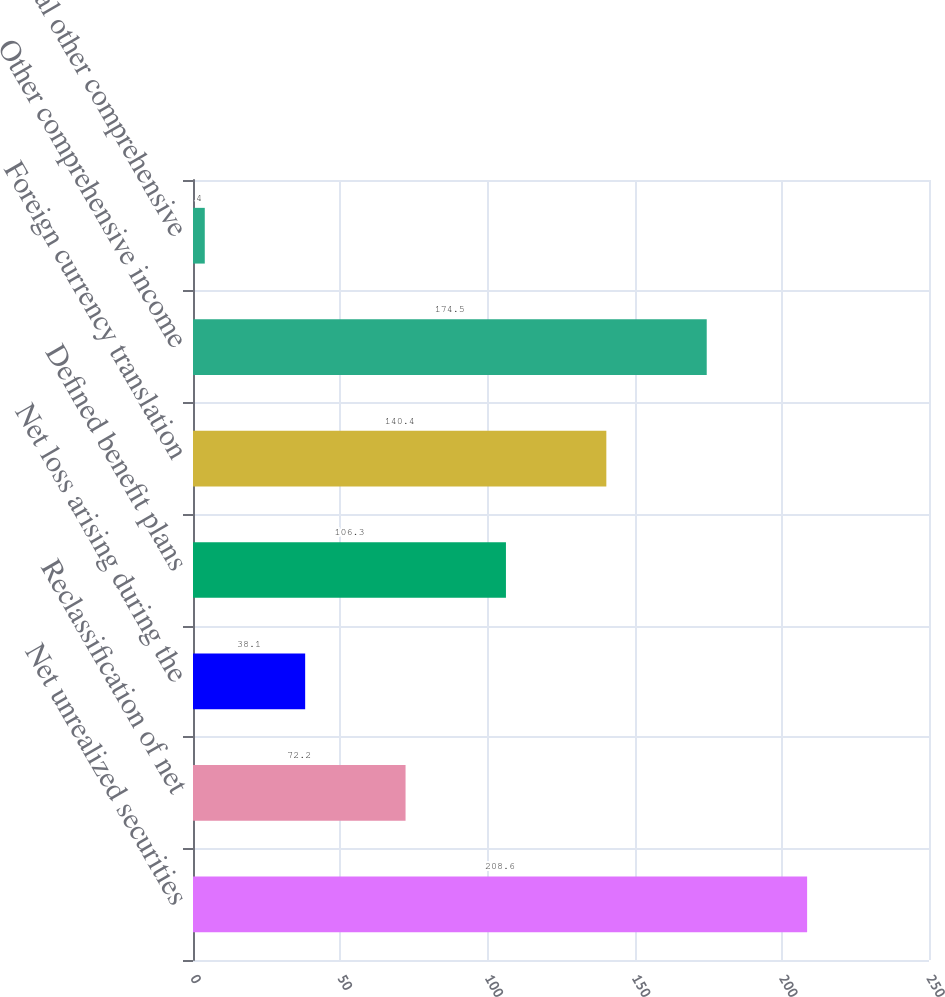<chart> <loc_0><loc_0><loc_500><loc_500><bar_chart><fcel>Net unrealized securities<fcel>Reclassification of net<fcel>Net loss arising during the<fcel>Defined benefit plans<fcel>Foreign currency translation<fcel>Other comprehensive income<fcel>Total other comprehensive<nl><fcel>208.6<fcel>72.2<fcel>38.1<fcel>106.3<fcel>140.4<fcel>174.5<fcel>4<nl></chart> 